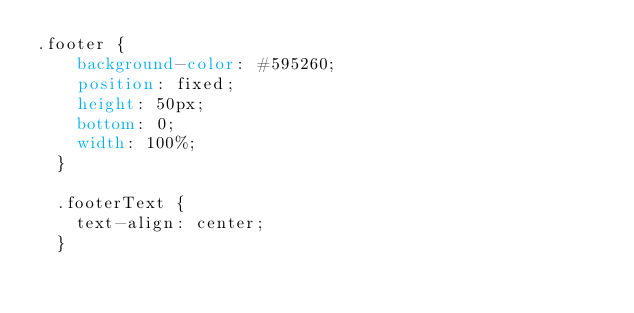<code> <loc_0><loc_0><loc_500><loc_500><_CSS_>.footer {
    background-color: #595260;
    position: fixed;
    height: 50px;
    bottom: 0;
    width: 100%;
  }
  
  .footerText {
    text-align: center;
  }</code> 